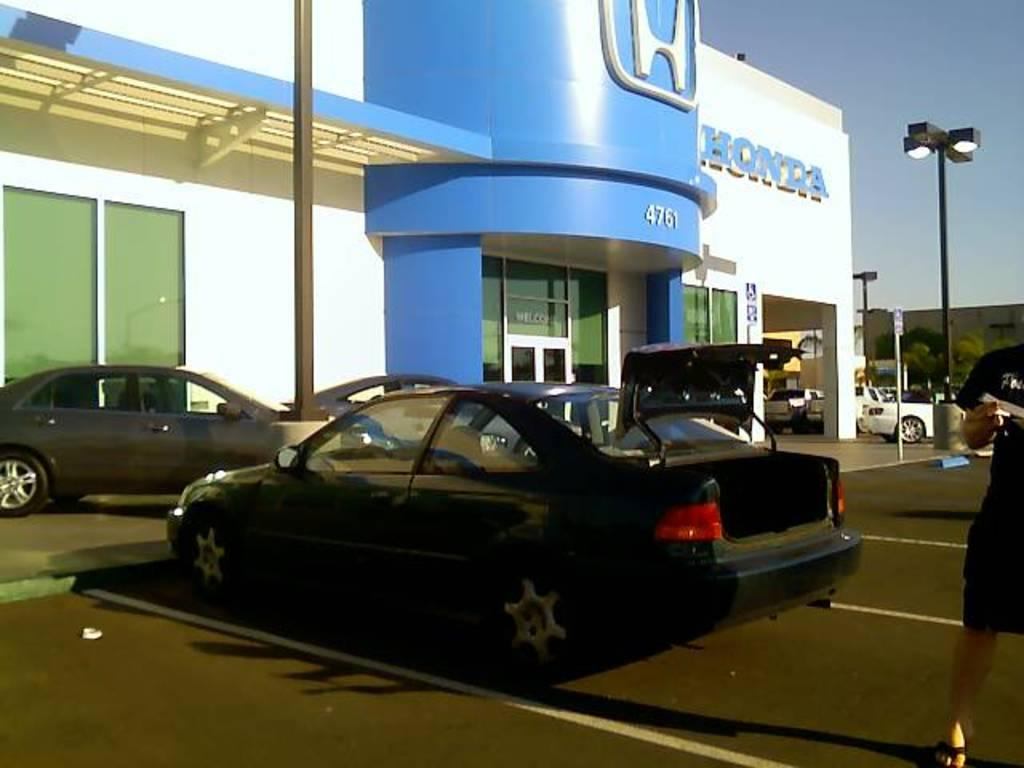What type of establishment is shown in the image? There is a Hyundai showroom in the image. What can be seen inside the showroom? There are cars in the image. What is the lighting source visible in the image? There is a street light in the image. What type of architectural features are present in the image? There are glass doors and windows in the image. What is the background of the image? There is a wall in the image. What is visible in the sky in the image? The sky is visible in the image. What type of meal is being prepared in the image? There is no meal being prepared in the image; it features a Hyundai showroom with cars and a street light. What type of poison is visible in the image? There is no poison present in the image. 